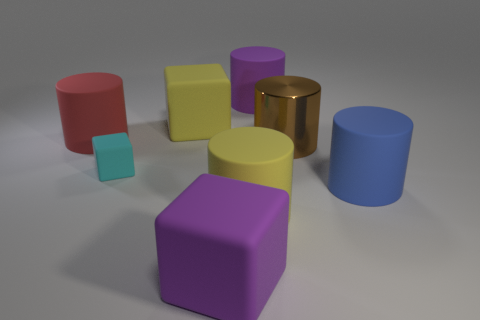Is there anything else of the same color as the tiny rubber cube?
Ensure brevity in your answer.  No. Is the color of the rubber cylinder to the right of the brown metal cylinder the same as the matte cylinder behind the red matte object?
Provide a short and direct response. No. Is the number of cylinders that are in front of the large red rubber cylinder greater than the number of purple matte objects in front of the blue matte object?
Offer a very short reply. Yes. What is the tiny cyan block made of?
Your response must be concise. Rubber. What shape is the large purple thing that is behind the red cylinder that is behind the yellow thing that is in front of the large metallic cylinder?
Offer a very short reply. Cylinder. What number of other things are made of the same material as the large blue cylinder?
Your answer should be very brief. 6. Does the purple object that is in front of the small cube have the same material as the yellow thing that is behind the red thing?
Make the answer very short. Yes. How many matte cylinders are behind the brown thing and right of the big red rubber cylinder?
Keep it short and to the point. 1. Is there a large blue shiny thing that has the same shape as the red matte thing?
Offer a terse response. No. What shape is the red rubber object that is the same size as the brown metallic object?
Offer a very short reply. Cylinder. 